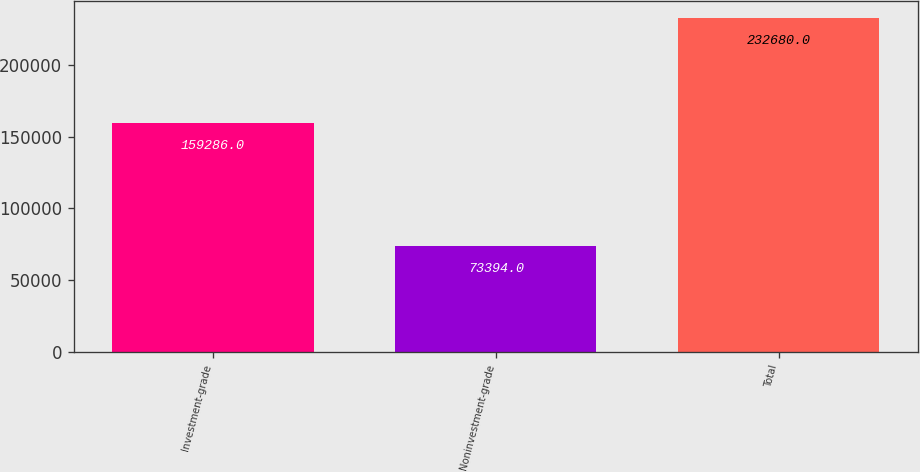Convert chart to OTSL. <chart><loc_0><loc_0><loc_500><loc_500><bar_chart><fcel>Investment-grade<fcel>Noninvestment-grade<fcel>Total<nl><fcel>159286<fcel>73394<fcel>232680<nl></chart> 